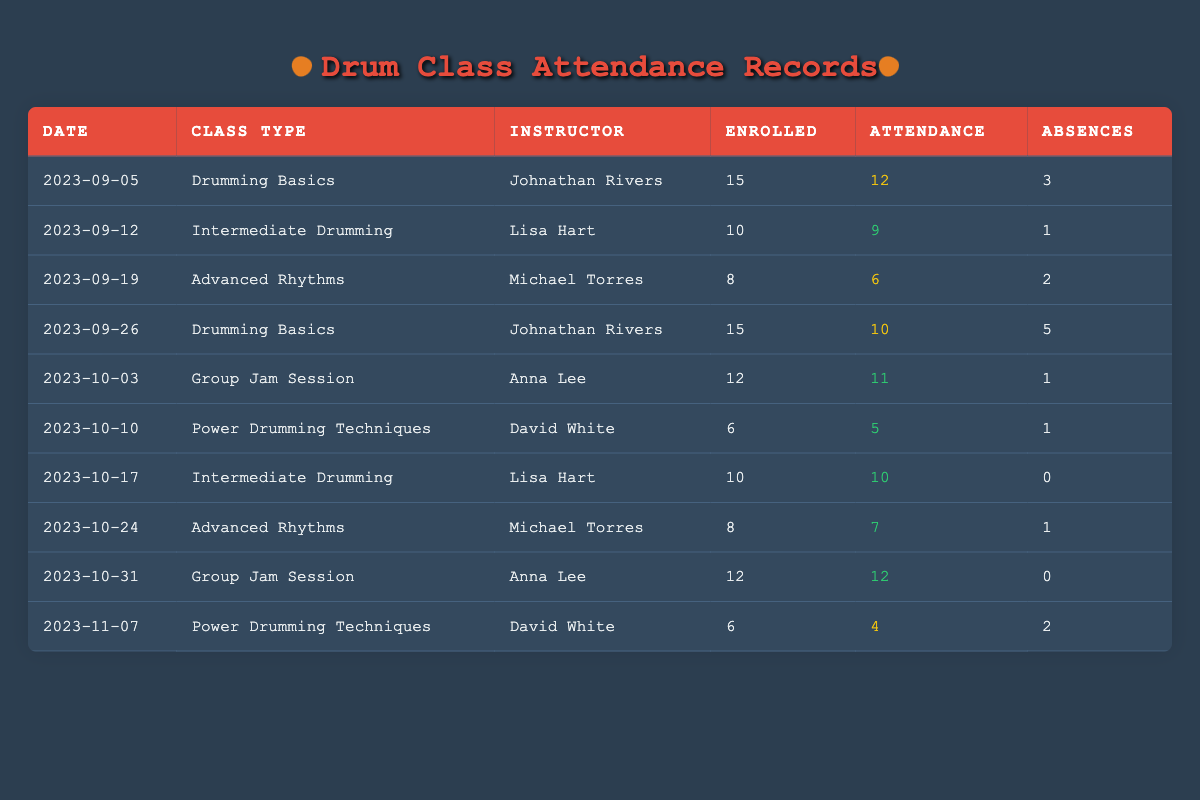What was the attendance on the session dated 2023-10-31? The table lists the attendance for each session, and for the date 2023-10-31, the attendance is explicitly mentioned as 12.
Answer: 12 How many students were absent in the class "Power Drumming Techniques" on 2023-10-10? The class "Power Drumming Techniques" has an entry for 2023-10-10, where the absences are listed as 1.
Answer: 1 Which instructor taught the "Advanced Rhythms" class on 2023-09-19? The session on 2023-09-19 for "Advanced Rhythms" shows that the instructor is Michael Torres.
Answer: Michael Torres What is the total attendance for all sessions of the "Group Jam Session"? The attendance records for both indicated sessions of "Group Jam Session" on 2023-10-03 and 2023-10-31 are 11 and 12 respectively. Summing these gives 11 + 12 = 23 for total attendance.
Answer: 23 Did "Intermediate Drumming" ever have full attendance of all enrolled students? By reviewing the attendance numbers for both sessions of "Intermediate Drumming," which are 9 out of 10 enrolled (on 2023-09-12) and 10 out of 10 enrolled (on 2023-10-17), the second session's attendance indicates full attendance.
Answer: Yes What percentage of students were absent in the "Drumming Basics" class on 2023-09-05? For the session on 2023-09-05, there were 3 absences out of 15 total enrolled students. To find the percentage: (3 / 15) * 100 = 20%.
Answer: 20% What is the average attendance for the "Power Drumming Techniques" class over its sessions? The attendance for "Power Drumming Techniques" on two occasions is 5 (on 2023-10-10) and 4 (on 2023-11-07). The sum of attendances is 5 + 4 = 9, and the average is 9 / 2 = 4.5.
Answer: 4.5 How many classes were taught by Lisa Hart during the semester? Lisa Hart is listed as the instructor for two distinct sessions: one for "Intermediate Drumming" on 2023-09-12 and one more on 2023-10-17. Thus, she taught a total of 2 classes.
Answer: 2 